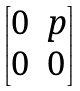<formula> <loc_0><loc_0><loc_500><loc_500>\begin{bmatrix} 0 & p \\ 0 & 0 \end{bmatrix}</formula> 